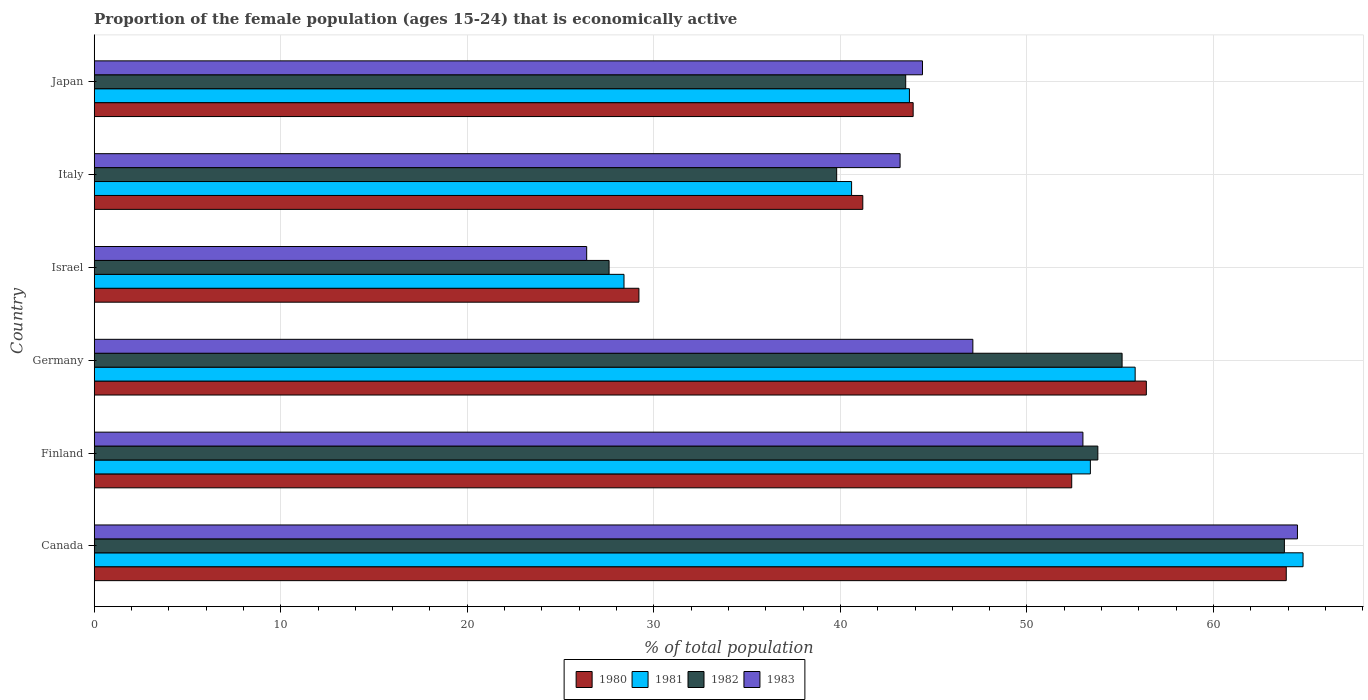How many different coloured bars are there?
Your answer should be compact. 4. Are the number of bars per tick equal to the number of legend labels?
Provide a succinct answer. Yes. How many bars are there on the 4th tick from the top?
Your answer should be compact. 4. What is the proportion of the female population that is economically active in 1982 in Israel?
Provide a succinct answer. 27.6. Across all countries, what is the maximum proportion of the female population that is economically active in 1981?
Provide a short and direct response. 64.8. Across all countries, what is the minimum proportion of the female population that is economically active in 1980?
Your response must be concise. 29.2. In which country was the proportion of the female population that is economically active in 1980 maximum?
Ensure brevity in your answer.  Canada. What is the total proportion of the female population that is economically active in 1983 in the graph?
Offer a terse response. 278.6. What is the difference between the proportion of the female population that is economically active in 1981 in Finland and that in Germany?
Offer a terse response. -2.4. What is the difference between the proportion of the female population that is economically active in 1982 in Italy and the proportion of the female population that is economically active in 1983 in Canada?
Your response must be concise. -24.7. What is the average proportion of the female population that is economically active in 1983 per country?
Provide a succinct answer. 46.43. What is the difference between the proportion of the female population that is economically active in 1982 and proportion of the female population that is economically active in 1983 in Germany?
Your answer should be very brief. 8. What is the ratio of the proportion of the female population that is economically active in 1982 in Finland to that in Israel?
Provide a short and direct response. 1.95. What is the difference between the highest and the second highest proportion of the female population that is economically active in 1980?
Offer a very short reply. 7.5. What is the difference between the highest and the lowest proportion of the female population that is economically active in 1982?
Ensure brevity in your answer.  36.2. In how many countries, is the proportion of the female population that is economically active in 1981 greater than the average proportion of the female population that is economically active in 1981 taken over all countries?
Your response must be concise. 3. Are the values on the major ticks of X-axis written in scientific E-notation?
Offer a very short reply. No. Where does the legend appear in the graph?
Give a very brief answer. Bottom center. How many legend labels are there?
Provide a short and direct response. 4. How are the legend labels stacked?
Ensure brevity in your answer.  Horizontal. What is the title of the graph?
Offer a very short reply. Proportion of the female population (ages 15-24) that is economically active. What is the label or title of the X-axis?
Offer a very short reply. % of total population. What is the % of total population in 1980 in Canada?
Keep it short and to the point. 63.9. What is the % of total population in 1981 in Canada?
Your answer should be compact. 64.8. What is the % of total population of 1982 in Canada?
Keep it short and to the point. 63.8. What is the % of total population in 1983 in Canada?
Offer a terse response. 64.5. What is the % of total population of 1980 in Finland?
Provide a succinct answer. 52.4. What is the % of total population in 1981 in Finland?
Provide a short and direct response. 53.4. What is the % of total population of 1982 in Finland?
Your answer should be compact. 53.8. What is the % of total population of 1983 in Finland?
Your answer should be very brief. 53. What is the % of total population of 1980 in Germany?
Give a very brief answer. 56.4. What is the % of total population in 1981 in Germany?
Give a very brief answer. 55.8. What is the % of total population in 1982 in Germany?
Make the answer very short. 55.1. What is the % of total population in 1983 in Germany?
Your answer should be very brief. 47.1. What is the % of total population in 1980 in Israel?
Keep it short and to the point. 29.2. What is the % of total population in 1981 in Israel?
Offer a terse response. 28.4. What is the % of total population of 1982 in Israel?
Make the answer very short. 27.6. What is the % of total population of 1983 in Israel?
Provide a succinct answer. 26.4. What is the % of total population in 1980 in Italy?
Your response must be concise. 41.2. What is the % of total population of 1981 in Italy?
Provide a short and direct response. 40.6. What is the % of total population of 1982 in Italy?
Make the answer very short. 39.8. What is the % of total population of 1983 in Italy?
Ensure brevity in your answer.  43.2. What is the % of total population of 1980 in Japan?
Offer a very short reply. 43.9. What is the % of total population in 1981 in Japan?
Provide a succinct answer. 43.7. What is the % of total population of 1982 in Japan?
Your response must be concise. 43.5. What is the % of total population of 1983 in Japan?
Offer a terse response. 44.4. Across all countries, what is the maximum % of total population in 1980?
Offer a terse response. 63.9. Across all countries, what is the maximum % of total population of 1981?
Provide a succinct answer. 64.8. Across all countries, what is the maximum % of total population in 1982?
Your answer should be very brief. 63.8. Across all countries, what is the maximum % of total population in 1983?
Give a very brief answer. 64.5. Across all countries, what is the minimum % of total population in 1980?
Offer a terse response. 29.2. Across all countries, what is the minimum % of total population in 1981?
Provide a succinct answer. 28.4. Across all countries, what is the minimum % of total population in 1982?
Keep it short and to the point. 27.6. Across all countries, what is the minimum % of total population of 1983?
Give a very brief answer. 26.4. What is the total % of total population of 1980 in the graph?
Give a very brief answer. 287. What is the total % of total population in 1981 in the graph?
Your response must be concise. 286.7. What is the total % of total population of 1982 in the graph?
Your answer should be very brief. 283.6. What is the total % of total population of 1983 in the graph?
Offer a very short reply. 278.6. What is the difference between the % of total population of 1980 in Canada and that in Finland?
Offer a very short reply. 11.5. What is the difference between the % of total population in 1983 in Canada and that in Finland?
Provide a short and direct response. 11.5. What is the difference between the % of total population in 1983 in Canada and that in Germany?
Make the answer very short. 17.4. What is the difference between the % of total population of 1980 in Canada and that in Israel?
Make the answer very short. 34.7. What is the difference between the % of total population of 1981 in Canada and that in Israel?
Provide a succinct answer. 36.4. What is the difference between the % of total population of 1982 in Canada and that in Israel?
Provide a short and direct response. 36.2. What is the difference between the % of total population of 1983 in Canada and that in Israel?
Ensure brevity in your answer.  38.1. What is the difference between the % of total population in 1980 in Canada and that in Italy?
Ensure brevity in your answer.  22.7. What is the difference between the % of total population in 1981 in Canada and that in Italy?
Your response must be concise. 24.2. What is the difference between the % of total population in 1982 in Canada and that in Italy?
Offer a very short reply. 24. What is the difference between the % of total population of 1983 in Canada and that in Italy?
Keep it short and to the point. 21.3. What is the difference between the % of total population in 1980 in Canada and that in Japan?
Make the answer very short. 20. What is the difference between the % of total population of 1981 in Canada and that in Japan?
Your answer should be compact. 21.1. What is the difference between the % of total population in 1982 in Canada and that in Japan?
Your response must be concise. 20.3. What is the difference between the % of total population in 1983 in Canada and that in Japan?
Your answer should be compact. 20.1. What is the difference between the % of total population of 1980 in Finland and that in Germany?
Keep it short and to the point. -4. What is the difference between the % of total population in 1981 in Finland and that in Germany?
Ensure brevity in your answer.  -2.4. What is the difference between the % of total population of 1980 in Finland and that in Israel?
Give a very brief answer. 23.2. What is the difference between the % of total population in 1982 in Finland and that in Israel?
Give a very brief answer. 26.2. What is the difference between the % of total population of 1983 in Finland and that in Israel?
Give a very brief answer. 26.6. What is the difference between the % of total population of 1980 in Finland and that in Italy?
Your answer should be compact. 11.2. What is the difference between the % of total population of 1982 in Finland and that in Italy?
Keep it short and to the point. 14. What is the difference between the % of total population of 1980 in Finland and that in Japan?
Give a very brief answer. 8.5. What is the difference between the % of total population of 1981 in Finland and that in Japan?
Your response must be concise. 9.7. What is the difference between the % of total population in 1983 in Finland and that in Japan?
Your answer should be very brief. 8.6. What is the difference between the % of total population of 1980 in Germany and that in Israel?
Give a very brief answer. 27.2. What is the difference between the % of total population in 1981 in Germany and that in Israel?
Provide a short and direct response. 27.4. What is the difference between the % of total population in 1983 in Germany and that in Israel?
Offer a very short reply. 20.7. What is the difference between the % of total population in 1980 in Germany and that in Italy?
Give a very brief answer. 15.2. What is the difference between the % of total population of 1982 in Germany and that in Italy?
Make the answer very short. 15.3. What is the difference between the % of total population in 1983 in Germany and that in Italy?
Provide a succinct answer. 3.9. What is the difference between the % of total population in 1981 in Germany and that in Japan?
Provide a short and direct response. 12.1. What is the difference between the % of total population in 1983 in Germany and that in Japan?
Make the answer very short. 2.7. What is the difference between the % of total population of 1981 in Israel and that in Italy?
Give a very brief answer. -12.2. What is the difference between the % of total population of 1982 in Israel and that in Italy?
Give a very brief answer. -12.2. What is the difference between the % of total population in 1983 in Israel and that in Italy?
Ensure brevity in your answer.  -16.8. What is the difference between the % of total population in 1980 in Israel and that in Japan?
Your answer should be very brief. -14.7. What is the difference between the % of total population in 1981 in Israel and that in Japan?
Your response must be concise. -15.3. What is the difference between the % of total population of 1982 in Israel and that in Japan?
Offer a very short reply. -15.9. What is the difference between the % of total population of 1983 in Israel and that in Japan?
Your answer should be very brief. -18. What is the difference between the % of total population of 1981 in Italy and that in Japan?
Give a very brief answer. -3.1. What is the difference between the % of total population of 1980 in Canada and the % of total population of 1981 in Finland?
Give a very brief answer. 10.5. What is the difference between the % of total population of 1980 in Canada and the % of total population of 1983 in Finland?
Your answer should be very brief. 10.9. What is the difference between the % of total population of 1981 in Canada and the % of total population of 1982 in Finland?
Offer a very short reply. 11. What is the difference between the % of total population in 1980 in Canada and the % of total population in 1981 in Germany?
Your answer should be very brief. 8.1. What is the difference between the % of total population in 1980 in Canada and the % of total population in 1983 in Germany?
Provide a succinct answer. 16.8. What is the difference between the % of total population in 1981 in Canada and the % of total population in 1982 in Germany?
Give a very brief answer. 9.7. What is the difference between the % of total population of 1980 in Canada and the % of total population of 1981 in Israel?
Your response must be concise. 35.5. What is the difference between the % of total population in 1980 in Canada and the % of total population in 1982 in Israel?
Keep it short and to the point. 36.3. What is the difference between the % of total population of 1980 in Canada and the % of total population of 1983 in Israel?
Provide a succinct answer. 37.5. What is the difference between the % of total population in 1981 in Canada and the % of total population in 1982 in Israel?
Offer a very short reply. 37.2. What is the difference between the % of total population of 1981 in Canada and the % of total population of 1983 in Israel?
Make the answer very short. 38.4. What is the difference between the % of total population of 1982 in Canada and the % of total population of 1983 in Israel?
Offer a very short reply. 37.4. What is the difference between the % of total population in 1980 in Canada and the % of total population in 1981 in Italy?
Provide a succinct answer. 23.3. What is the difference between the % of total population in 1980 in Canada and the % of total population in 1982 in Italy?
Ensure brevity in your answer.  24.1. What is the difference between the % of total population of 1980 in Canada and the % of total population of 1983 in Italy?
Your answer should be very brief. 20.7. What is the difference between the % of total population of 1981 in Canada and the % of total population of 1982 in Italy?
Provide a succinct answer. 25. What is the difference between the % of total population of 1981 in Canada and the % of total population of 1983 in Italy?
Keep it short and to the point. 21.6. What is the difference between the % of total population of 1982 in Canada and the % of total population of 1983 in Italy?
Offer a terse response. 20.6. What is the difference between the % of total population of 1980 in Canada and the % of total population of 1981 in Japan?
Ensure brevity in your answer.  20.2. What is the difference between the % of total population of 1980 in Canada and the % of total population of 1982 in Japan?
Your answer should be very brief. 20.4. What is the difference between the % of total population of 1981 in Canada and the % of total population of 1982 in Japan?
Keep it short and to the point. 21.3. What is the difference between the % of total population of 1981 in Canada and the % of total population of 1983 in Japan?
Provide a succinct answer. 20.4. What is the difference between the % of total population in 1982 in Canada and the % of total population in 1983 in Japan?
Keep it short and to the point. 19.4. What is the difference between the % of total population of 1980 in Finland and the % of total population of 1981 in Germany?
Your response must be concise. -3.4. What is the difference between the % of total population in 1980 in Finland and the % of total population in 1983 in Germany?
Your response must be concise. 5.3. What is the difference between the % of total population in 1980 in Finland and the % of total population in 1981 in Israel?
Offer a terse response. 24. What is the difference between the % of total population of 1980 in Finland and the % of total population of 1982 in Israel?
Your answer should be very brief. 24.8. What is the difference between the % of total population of 1980 in Finland and the % of total population of 1983 in Israel?
Your response must be concise. 26. What is the difference between the % of total population of 1981 in Finland and the % of total population of 1982 in Israel?
Give a very brief answer. 25.8. What is the difference between the % of total population in 1981 in Finland and the % of total population in 1983 in Israel?
Offer a terse response. 27. What is the difference between the % of total population of 1982 in Finland and the % of total population of 1983 in Israel?
Your answer should be compact. 27.4. What is the difference between the % of total population in 1980 in Finland and the % of total population in 1982 in Italy?
Your answer should be very brief. 12.6. What is the difference between the % of total population of 1980 in Finland and the % of total population of 1983 in Italy?
Your response must be concise. 9.2. What is the difference between the % of total population in 1982 in Finland and the % of total population in 1983 in Italy?
Give a very brief answer. 10.6. What is the difference between the % of total population of 1982 in Finland and the % of total population of 1983 in Japan?
Give a very brief answer. 9.4. What is the difference between the % of total population of 1980 in Germany and the % of total population of 1981 in Israel?
Keep it short and to the point. 28. What is the difference between the % of total population in 1980 in Germany and the % of total population in 1982 in Israel?
Make the answer very short. 28.8. What is the difference between the % of total population of 1980 in Germany and the % of total population of 1983 in Israel?
Offer a terse response. 30. What is the difference between the % of total population in 1981 in Germany and the % of total population in 1982 in Israel?
Your answer should be compact. 28.2. What is the difference between the % of total population in 1981 in Germany and the % of total population in 1983 in Israel?
Keep it short and to the point. 29.4. What is the difference between the % of total population of 1982 in Germany and the % of total population of 1983 in Israel?
Your answer should be compact. 28.7. What is the difference between the % of total population of 1980 in Germany and the % of total population of 1981 in Italy?
Give a very brief answer. 15.8. What is the difference between the % of total population of 1981 in Germany and the % of total population of 1983 in Italy?
Your answer should be compact. 12.6. What is the difference between the % of total population in 1980 in Germany and the % of total population in 1981 in Japan?
Offer a terse response. 12.7. What is the difference between the % of total population in 1980 in Germany and the % of total population in 1982 in Japan?
Provide a short and direct response. 12.9. What is the difference between the % of total population of 1980 in Germany and the % of total population of 1983 in Japan?
Offer a terse response. 12. What is the difference between the % of total population in 1980 in Israel and the % of total population in 1983 in Italy?
Give a very brief answer. -14. What is the difference between the % of total population of 1981 in Israel and the % of total population of 1982 in Italy?
Provide a succinct answer. -11.4. What is the difference between the % of total population of 1981 in Israel and the % of total population of 1983 in Italy?
Provide a succinct answer. -14.8. What is the difference between the % of total population in 1982 in Israel and the % of total population in 1983 in Italy?
Make the answer very short. -15.6. What is the difference between the % of total population of 1980 in Israel and the % of total population of 1982 in Japan?
Make the answer very short. -14.3. What is the difference between the % of total population in 1980 in Israel and the % of total population in 1983 in Japan?
Your response must be concise. -15.2. What is the difference between the % of total population in 1981 in Israel and the % of total population in 1982 in Japan?
Offer a terse response. -15.1. What is the difference between the % of total population of 1982 in Israel and the % of total population of 1983 in Japan?
Your answer should be compact. -16.8. What is the difference between the % of total population of 1980 in Italy and the % of total population of 1981 in Japan?
Provide a short and direct response. -2.5. What is the difference between the % of total population of 1980 in Italy and the % of total population of 1983 in Japan?
Provide a short and direct response. -3.2. What is the difference between the % of total population of 1981 in Italy and the % of total population of 1982 in Japan?
Make the answer very short. -2.9. What is the difference between the % of total population of 1982 in Italy and the % of total population of 1983 in Japan?
Your response must be concise. -4.6. What is the average % of total population of 1980 per country?
Your answer should be very brief. 47.83. What is the average % of total population in 1981 per country?
Offer a very short reply. 47.78. What is the average % of total population of 1982 per country?
Ensure brevity in your answer.  47.27. What is the average % of total population of 1983 per country?
Provide a succinct answer. 46.43. What is the difference between the % of total population of 1981 and % of total population of 1982 in Canada?
Offer a terse response. 1. What is the difference between the % of total population of 1981 and % of total population of 1982 in Finland?
Your answer should be very brief. -0.4. What is the difference between the % of total population of 1981 and % of total population of 1983 in Finland?
Provide a succinct answer. 0.4. What is the difference between the % of total population of 1982 and % of total population of 1983 in Finland?
Provide a short and direct response. 0.8. What is the difference between the % of total population in 1980 and % of total population in 1983 in Germany?
Make the answer very short. 9.3. What is the difference between the % of total population of 1981 and % of total population of 1982 in Germany?
Provide a succinct answer. 0.7. What is the difference between the % of total population of 1980 and % of total population of 1981 in Israel?
Give a very brief answer. 0.8. What is the difference between the % of total population of 1980 and % of total population of 1982 in Israel?
Make the answer very short. 1.6. What is the difference between the % of total population of 1981 and % of total population of 1983 in Israel?
Ensure brevity in your answer.  2. What is the difference between the % of total population of 1980 and % of total population of 1981 in Italy?
Your answer should be very brief. 0.6. What is the difference between the % of total population in 1980 and % of total population in 1982 in Italy?
Offer a terse response. 1.4. What is the difference between the % of total population of 1980 and % of total population of 1983 in Italy?
Give a very brief answer. -2. What is the difference between the % of total population in 1982 and % of total population in 1983 in Italy?
Ensure brevity in your answer.  -3.4. What is the difference between the % of total population in 1980 and % of total population in 1981 in Japan?
Offer a terse response. 0.2. What is the difference between the % of total population of 1981 and % of total population of 1982 in Japan?
Keep it short and to the point. 0.2. What is the difference between the % of total population of 1981 and % of total population of 1983 in Japan?
Offer a terse response. -0.7. What is the ratio of the % of total population of 1980 in Canada to that in Finland?
Offer a terse response. 1.22. What is the ratio of the % of total population of 1981 in Canada to that in Finland?
Provide a short and direct response. 1.21. What is the ratio of the % of total population in 1982 in Canada to that in Finland?
Your response must be concise. 1.19. What is the ratio of the % of total population in 1983 in Canada to that in Finland?
Provide a short and direct response. 1.22. What is the ratio of the % of total population in 1980 in Canada to that in Germany?
Provide a short and direct response. 1.13. What is the ratio of the % of total population in 1981 in Canada to that in Germany?
Your answer should be very brief. 1.16. What is the ratio of the % of total population of 1982 in Canada to that in Germany?
Your answer should be compact. 1.16. What is the ratio of the % of total population in 1983 in Canada to that in Germany?
Keep it short and to the point. 1.37. What is the ratio of the % of total population in 1980 in Canada to that in Israel?
Your answer should be very brief. 2.19. What is the ratio of the % of total population in 1981 in Canada to that in Israel?
Your answer should be very brief. 2.28. What is the ratio of the % of total population in 1982 in Canada to that in Israel?
Provide a succinct answer. 2.31. What is the ratio of the % of total population in 1983 in Canada to that in Israel?
Provide a short and direct response. 2.44. What is the ratio of the % of total population in 1980 in Canada to that in Italy?
Make the answer very short. 1.55. What is the ratio of the % of total population of 1981 in Canada to that in Italy?
Make the answer very short. 1.6. What is the ratio of the % of total population in 1982 in Canada to that in Italy?
Provide a succinct answer. 1.6. What is the ratio of the % of total population in 1983 in Canada to that in Italy?
Keep it short and to the point. 1.49. What is the ratio of the % of total population in 1980 in Canada to that in Japan?
Your answer should be very brief. 1.46. What is the ratio of the % of total population in 1981 in Canada to that in Japan?
Offer a very short reply. 1.48. What is the ratio of the % of total population in 1982 in Canada to that in Japan?
Give a very brief answer. 1.47. What is the ratio of the % of total population of 1983 in Canada to that in Japan?
Offer a terse response. 1.45. What is the ratio of the % of total population of 1980 in Finland to that in Germany?
Offer a terse response. 0.93. What is the ratio of the % of total population of 1982 in Finland to that in Germany?
Your answer should be compact. 0.98. What is the ratio of the % of total population of 1983 in Finland to that in Germany?
Your answer should be very brief. 1.13. What is the ratio of the % of total population in 1980 in Finland to that in Israel?
Offer a terse response. 1.79. What is the ratio of the % of total population of 1981 in Finland to that in Israel?
Your answer should be compact. 1.88. What is the ratio of the % of total population of 1982 in Finland to that in Israel?
Give a very brief answer. 1.95. What is the ratio of the % of total population of 1983 in Finland to that in Israel?
Provide a short and direct response. 2.01. What is the ratio of the % of total population in 1980 in Finland to that in Italy?
Give a very brief answer. 1.27. What is the ratio of the % of total population in 1981 in Finland to that in Italy?
Make the answer very short. 1.32. What is the ratio of the % of total population in 1982 in Finland to that in Italy?
Offer a terse response. 1.35. What is the ratio of the % of total population in 1983 in Finland to that in Italy?
Your answer should be compact. 1.23. What is the ratio of the % of total population of 1980 in Finland to that in Japan?
Offer a terse response. 1.19. What is the ratio of the % of total population in 1981 in Finland to that in Japan?
Your answer should be very brief. 1.22. What is the ratio of the % of total population in 1982 in Finland to that in Japan?
Ensure brevity in your answer.  1.24. What is the ratio of the % of total population of 1983 in Finland to that in Japan?
Your answer should be very brief. 1.19. What is the ratio of the % of total population of 1980 in Germany to that in Israel?
Offer a very short reply. 1.93. What is the ratio of the % of total population in 1981 in Germany to that in Israel?
Offer a terse response. 1.96. What is the ratio of the % of total population in 1982 in Germany to that in Israel?
Provide a short and direct response. 2. What is the ratio of the % of total population in 1983 in Germany to that in Israel?
Give a very brief answer. 1.78. What is the ratio of the % of total population in 1980 in Germany to that in Italy?
Give a very brief answer. 1.37. What is the ratio of the % of total population of 1981 in Germany to that in Italy?
Give a very brief answer. 1.37. What is the ratio of the % of total population of 1982 in Germany to that in Italy?
Make the answer very short. 1.38. What is the ratio of the % of total population of 1983 in Germany to that in Italy?
Your answer should be very brief. 1.09. What is the ratio of the % of total population of 1980 in Germany to that in Japan?
Your answer should be compact. 1.28. What is the ratio of the % of total population in 1981 in Germany to that in Japan?
Your answer should be compact. 1.28. What is the ratio of the % of total population in 1982 in Germany to that in Japan?
Your answer should be very brief. 1.27. What is the ratio of the % of total population of 1983 in Germany to that in Japan?
Your response must be concise. 1.06. What is the ratio of the % of total population in 1980 in Israel to that in Italy?
Provide a short and direct response. 0.71. What is the ratio of the % of total population of 1981 in Israel to that in Italy?
Offer a very short reply. 0.7. What is the ratio of the % of total population in 1982 in Israel to that in Italy?
Provide a succinct answer. 0.69. What is the ratio of the % of total population of 1983 in Israel to that in Italy?
Keep it short and to the point. 0.61. What is the ratio of the % of total population in 1980 in Israel to that in Japan?
Keep it short and to the point. 0.67. What is the ratio of the % of total population in 1981 in Israel to that in Japan?
Ensure brevity in your answer.  0.65. What is the ratio of the % of total population in 1982 in Israel to that in Japan?
Offer a very short reply. 0.63. What is the ratio of the % of total population of 1983 in Israel to that in Japan?
Give a very brief answer. 0.59. What is the ratio of the % of total population in 1980 in Italy to that in Japan?
Provide a short and direct response. 0.94. What is the ratio of the % of total population of 1981 in Italy to that in Japan?
Give a very brief answer. 0.93. What is the ratio of the % of total population in 1982 in Italy to that in Japan?
Provide a succinct answer. 0.91. What is the difference between the highest and the second highest % of total population of 1980?
Provide a short and direct response. 7.5. What is the difference between the highest and the second highest % of total population of 1981?
Your answer should be very brief. 9. What is the difference between the highest and the second highest % of total population of 1982?
Your answer should be compact. 8.7. What is the difference between the highest and the second highest % of total population in 1983?
Ensure brevity in your answer.  11.5. What is the difference between the highest and the lowest % of total population of 1980?
Provide a succinct answer. 34.7. What is the difference between the highest and the lowest % of total population in 1981?
Ensure brevity in your answer.  36.4. What is the difference between the highest and the lowest % of total population of 1982?
Your answer should be compact. 36.2. What is the difference between the highest and the lowest % of total population of 1983?
Offer a terse response. 38.1. 